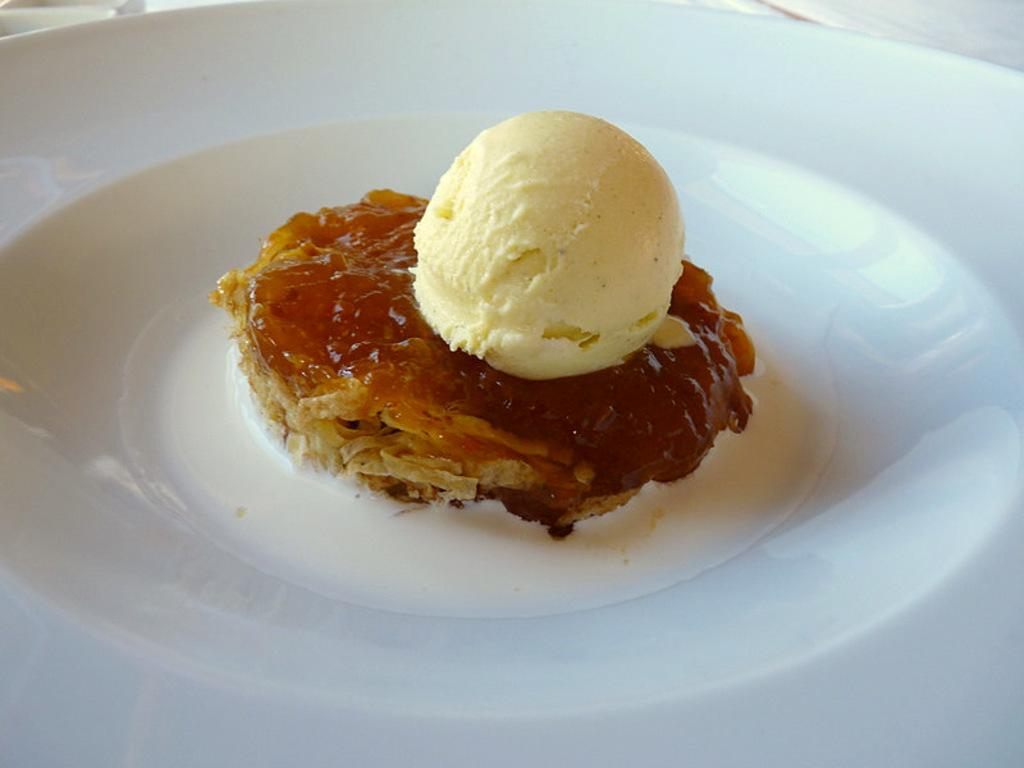What type of dessert is visible in the image? There is an ice cream in the image. What other type of dessert can be seen in the image? There is a sweet in the image. How are the ice cream and sweet arranged in the image? The ice cream and sweet are placed on a white plate. What type of umbrella is being used to protect the ice cream from the sun in the image? There is no umbrella present in the image, and the ice cream is not being protected from the sun. 